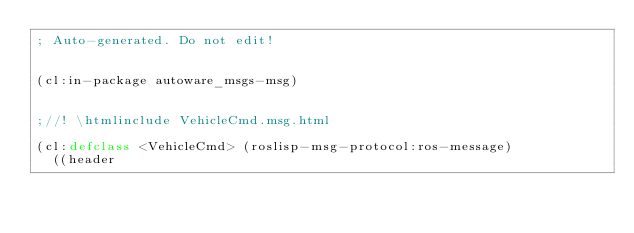<code> <loc_0><loc_0><loc_500><loc_500><_Lisp_>; Auto-generated. Do not edit!


(cl:in-package autoware_msgs-msg)


;//! \htmlinclude VehicleCmd.msg.html

(cl:defclass <VehicleCmd> (roslisp-msg-protocol:ros-message)
  ((header</code> 